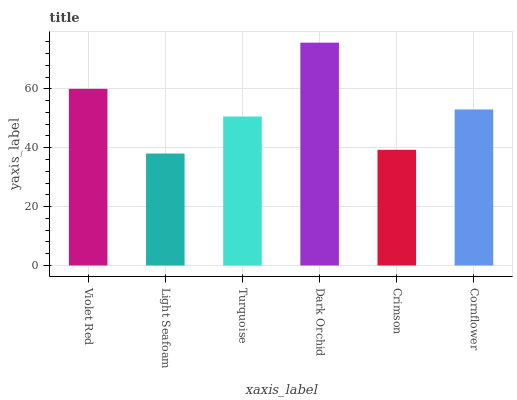Is Light Seafoam the minimum?
Answer yes or no. Yes. Is Dark Orchid the maximum?
Answer yes or no. Yes. Is Turquoise the minimum?
Answer yes or no. No. Is Turquoise the maximum?
Answer yes or no. No. Is Turquoise greater than Light Seafoam?
Answer yes or no. Yes. Is Light Seafoam less than Turquoise?
Answer yes or no. Yes. Is Light Seafoam greater than Turquoise?
Answer yes or no. No. Is Turquoise less than Light Seafoam?
Answer yes or no. No. Is Cornflower the high median?
Answer yes or no. Yes. Is Turquoise the low median?
Answer yes or no. Yes. Is Turquoise the high median?
Answer yes or no. No. Is Light Seafoam the low median?
Answer yes or no. No. 